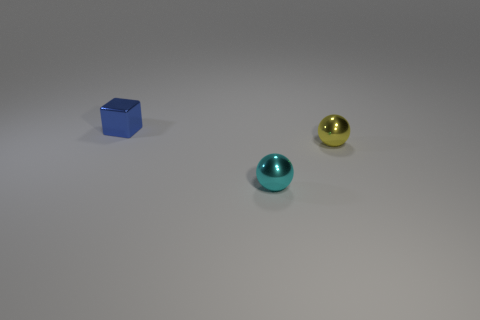Add 1 small objects. How many objects exist? 4 Add 1 yellow matte blocks. How many yellow matte blocks exist? 1 Subtract all cyan balls. How many balls are left? 1 Subtract 0 brown blocks. How many objects are left? 3 Subtract all spheres. How many objects are left? 1 Subtract 2 balls. How many balls are left? 0 Subtract all red blocks. Subtract all red spheres. How many blocks are left? 1 Subtract all green spheres. How many brown blocks are left? 0 Subtract all tiny metallic things. Subtract all large things. How many objects are left? 0 Add 2 blue metal blocks. How many blue metal blocks are left? 3 